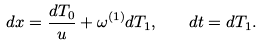<formula> <loc_0><loc_0><loc_500><loc_500>d x = \frac { d T _ { 0 } } { u } + \omega ^ { ( 1 ) } d T _ { 1 } , \quad d t = d T _ { 1 } .</formula> 